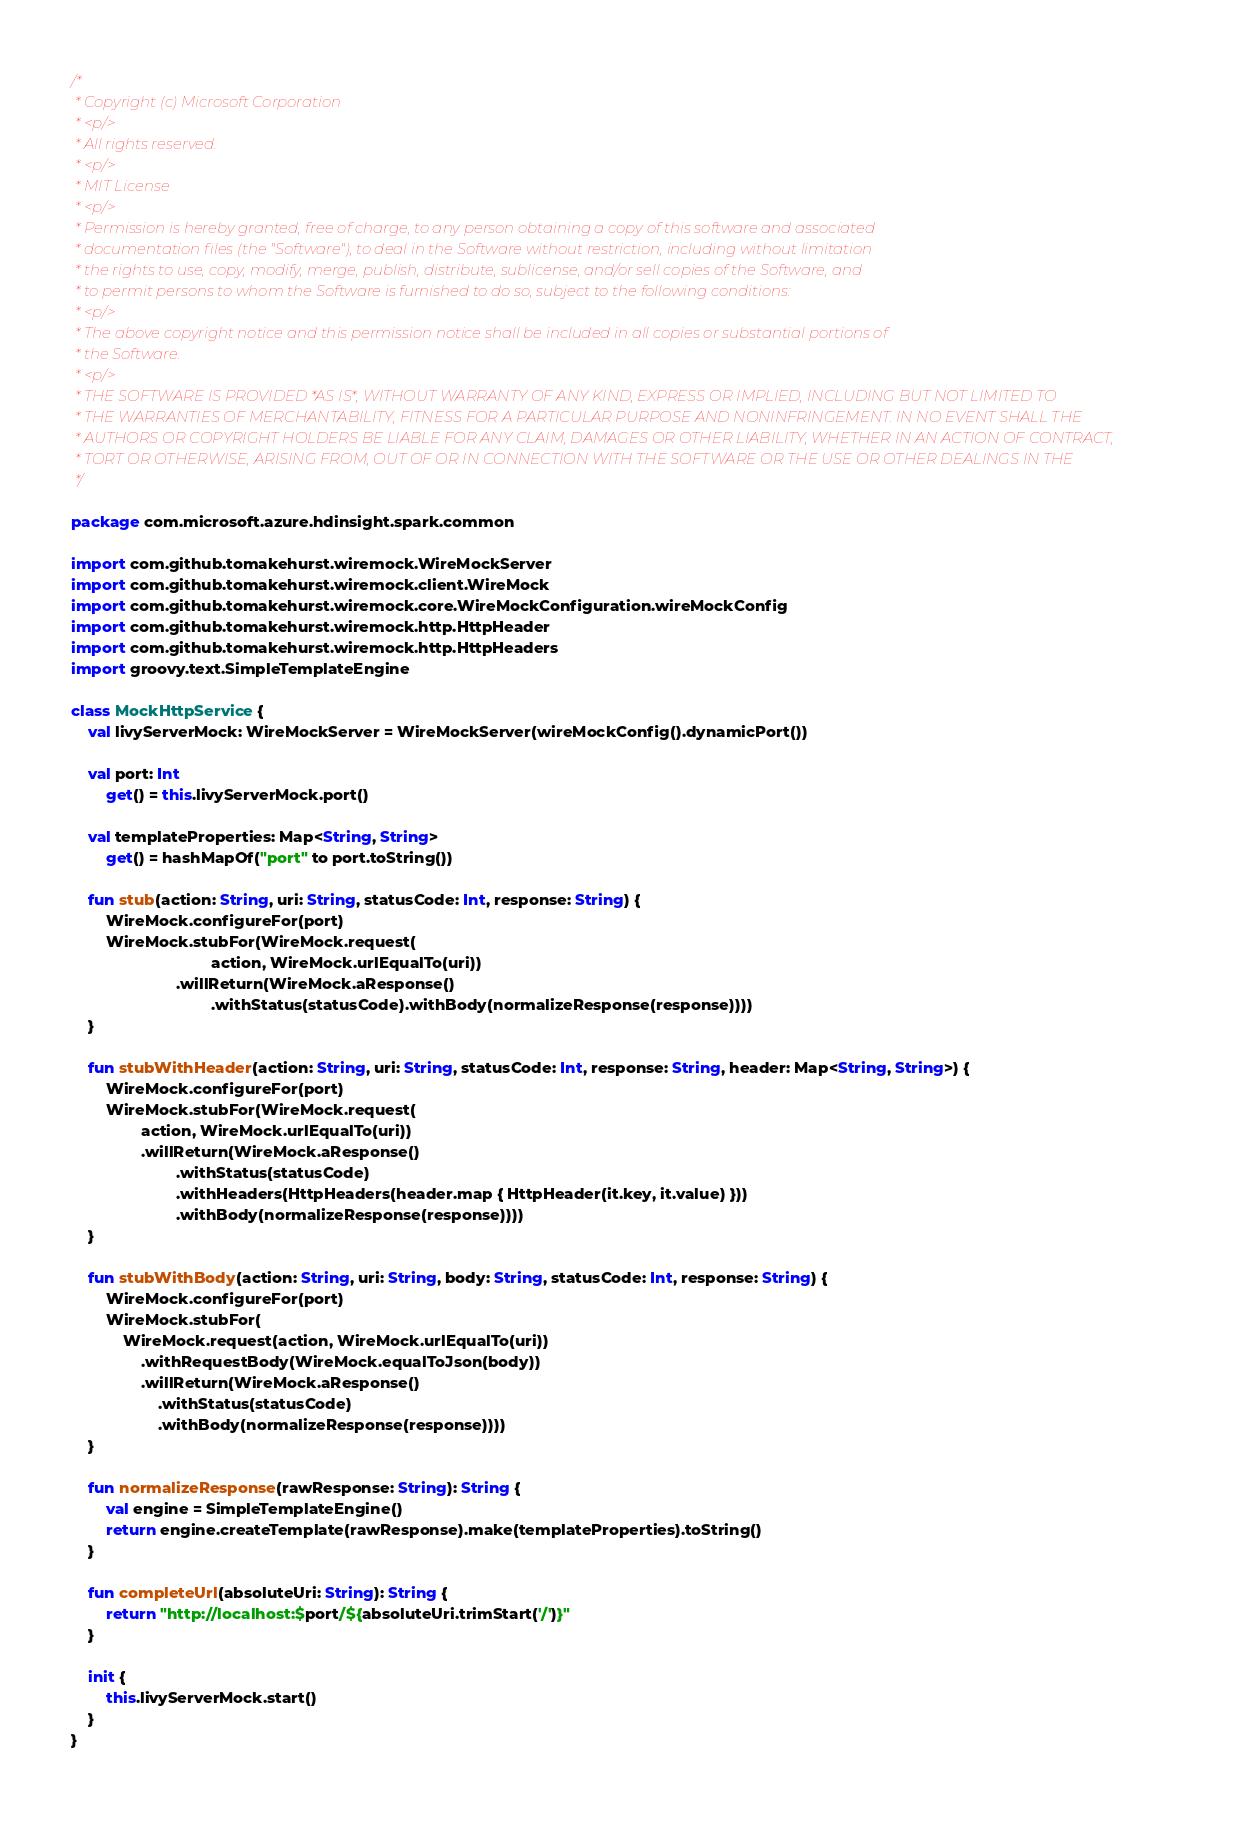Convert code to text. <code><loc_0><loc_0><loc_500><loc_500><_Kotlin_>/*
 * Copyright (c) Microsoft Corporation
 * <p/>
 * All rights reserved.
 * <p/>
 * MIT License
 * <p/>
 * Permission is hereby granted, free of charge, to any person obtaining a copy of this software and associated
 * documentation files (the "Software"), to deal in the Software without restriction, including without limitation
 * the rights to use, copy, modify, merge, publish, distribute, sublicense, and/or sell copies of the Software, and
 * to permit persons to whom the Software is furnished to do so, subject to the following conditions:
 * <p/>
 * The above copyright notice and this permission notice shall be included in all copies or substantial portions of
 * the Software.
 * <p/>
 * THE SOFTWARE IS PROVIDED *AS IS*, WITHOUT WARRANTY OF ANY KIND, EXPRESS OR IMPLIED, INCLUDING BUT NOT LIMITED TO
 * THE WARRANTIES OF MERCHANTABILITY, FITNESS FOR A PARTICULAR PURPOSE AND NONINFRINGEMENT. IN NO EVENT SHALL THE
 * AUTHORS OR COPYRIGHT HOLDERS BE LIABLE FOR ANY CLAIM, DAMAGES OR OTHER LIABILITY, WHETHER IN AN ACTION OF CONTRACT,
 * TORT OR OTHERWISE, ARISING FROM, OUT OF OR IN CONNECTION WITH THE SOFTWARE OR THE USE OR OTHER DEALINGS IN THE
 */

package com.microsoft.azure.hdinsight.spark.common

import com.github.tomakehurst.wiremock.WireMockServer
import com.github.tomakehurst.wiremock.client.WireMock
import com.github.tomakehurst.wiremock.core.WireMockConfiguration.wireMockConfig
import com.github.tomakehurst.wiremock.http.HttpHeader
import com.github.tomakehurst.wiremock.http.HttpHeaders
import groovy.text.SimpleTemplateEngine

class MockHttpService {
    val livyServerMock: WireMockServer = WireMockServer(wireMockConfig().dynamicPort())

    val port: Int
        get() = this.livyServerMock.port()

    val templateProperties: Map<String, String>
        get() = hashMapOf("port" to port.toString())

    fun stub(action: String, uri: String, statusCode: Int, response: String) {
        WireMock.configureFor(port)
        WireMock.stubFor(WireMock.request(
                                action, WireMock.urlEqualTo(uri))
                        .willReturn(WireMock.aResponse()
                                .withStatus(statusCode).withBody(normalizeResponse(response))))
    }

    fun stubWithHeader(action: String, uri: String, statusCode: Int, response: String, header: Map<String, String>) {
        WireMock.configureFor(port)
        WireMock.stubFor(WireMock.request(
                action, WireMock.urlEqualTo(uri))
                .willReturn(WireMock.aResponse()
                        .withStatus(statusCode)
                        .withHeaders(HttpHeaders(header.map { HttpHeader(it.key, it.value) }))
                        .withBody(normalizeResponse(response))))
    }

    fun stubWithBody(action: String, uri: String, body: String, statusCode: Int, response: String) {
        WireMock.configureFor(port)
        WireMock.stubFor(
            WireMock.request(action, WireMock.urlEqualTo(uri))
                .withRequestBody(WireMock.equalToJson(body))
                .willReturn(WireMock.aResponse()
                    .withStatus(statusCode)
                    .withBody(normalizeResponse(response))))
    }

    fun normalizeResponse(rawResponse: String): String {
        val engine = SimpleTemplateEngine()
        return engine.createTemplate(rawResponse).make(templateProperties).toString()
    }

    fun completeUrl(absoluteUri: String): String {
        return "http://localhost:$port/${absoluteUri.trimStart('/')}"
    }

    init {
        this.livyServerMock.start()
    }
}</code> 